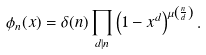<formula> <loc_0><loc_0><loc_500><loc_500>\phi _ { n } ( x ) = \delta ( n ) \prod _ { d | n } \left ( 1 - x ^ { d } \right ) ^ { \mu \left ( \frac { n } { d } \right ) } .</formula> 